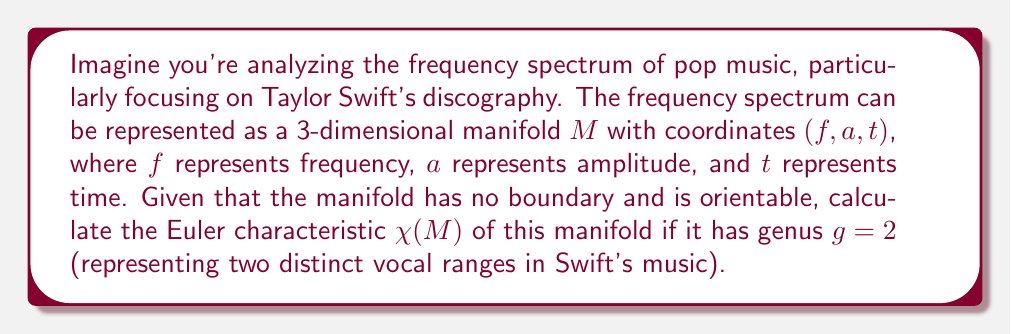What is the answer to this math problem? To solve this problem, we need to understand the relationship between the genus of a manifold and its Euler characteristic. For a closed, orientable surface (2-manifold), the Euler characteristic is related to the genus by the formula:

$$\chi(M) = 2 - 2g$$

Where:
- $\chi(M)$ is the Euler characteristic of the manifold $M$
- $g$ is the genus of the manifold

In this case, we are given that:
1. The manifold $M$ represents the frequency spectrum of pop music (specifically Taylor Swift's discography)
2. $M$ is a 3-dimensional manifold, but we're focusing on its surface properties
3. $M$ has no boundary and is orientable
4. The genus $g = 2$, representing two distinct vocal ranges in Swift's music

Let's plug these values into the formula:

$$\chi(M) = 2 - 2g$$
$$\chi(M) = 2 - 2(2)$$
$$\chi(M) = 2 - 4$$
$$\chi(M) = -2$$

Therefore, the Euler characteristic of the manifold $M$ is -2.

This negative Euler characteristic indicates that the surface of our frequency spectrum manifold has a complex topology, which aligns with the idea of analyzing the intricate patterns in pop music frequencies over time and amplitude.
Answer: $\chi(M) = -2$ 